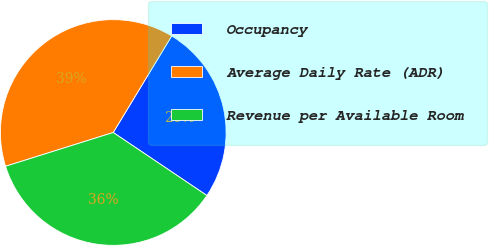Convert chart. <chart><loc_0><loc_0><loc_500><loc_500><pie_chart><fcel>Occupancy<fcel>Average Daily Rate (ADR)<fcel>Revenue per Available Room<nl><fcel>25.76%<fcel>38.5%<fcel>35.73%<nl></chart> 